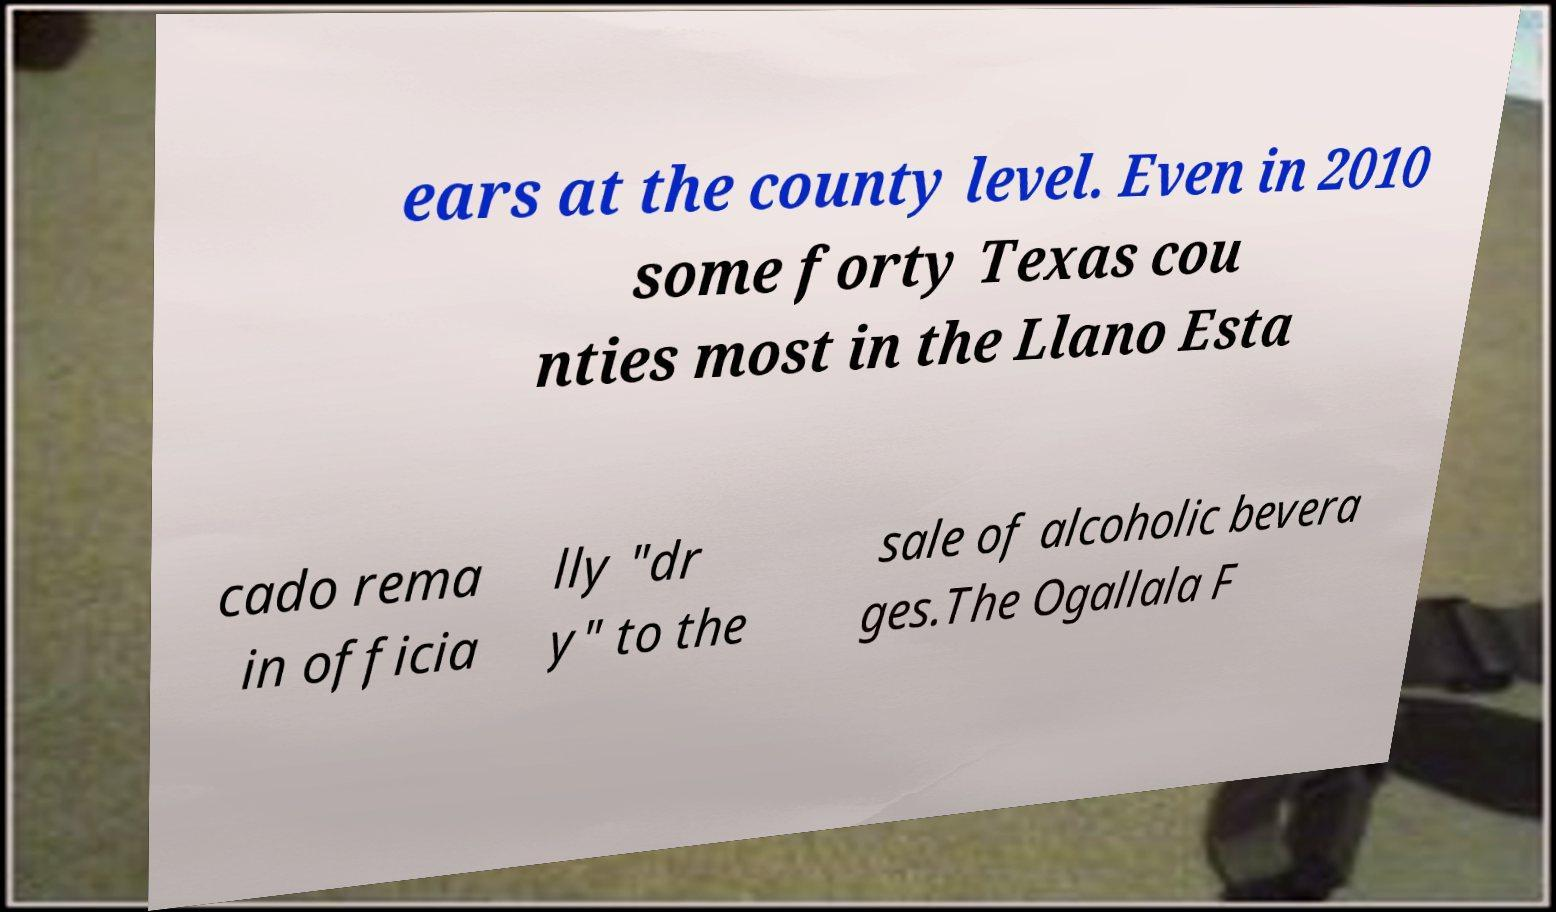Can you accurately transcribe the text from the provided image for me? ears at the county level. Even in 2010 some forty Texas cou nties most in the Llano Esta cado rema in officia lly "dr y" to the sale of alcoholic bevera ges.The Ogallala F 